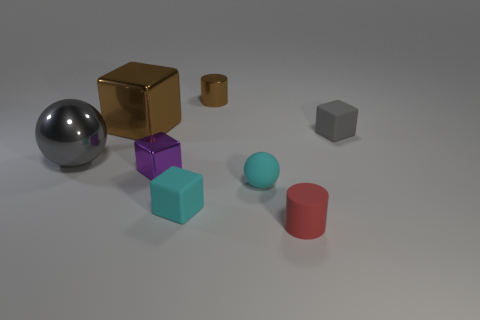Is the rubber cylinder the same color as the matte sphere?
Your answer should be compact. No. The cyan object in front of the ball on the right side of the metal thing that is to the left of the large shiny block is what shape?
Ensure brevity in your answer.  Cube. How many things are metallic things behind the purple block or matte cubes behind the cyan matte ball?
Offer a very short reply. 4. There is a cylinder in front of the cylinder that is behind the tiny gray matte object; how big is it?
Your response must be concise. Small. Is the color of the tiny rubber block on the left side of the tiny shiny cylinder the same as the tiny shiny block?
Offer a terse response. No. Is there a cyan matte object of the same shape as the red thing?
Offer a very short reply. No. What is the color of the shiny cylinder that is the same size as the matte ball?
Provide a short and direct response. Brown. There is a shiny object to the right of the tiny cyan matte block; what is its size?
Offer a very short reply. Small. There is a cylinder behind the tiny red thing; is there a small gray cube behind it?
Give a very brief answer. No. Is the material of the object that is to the left of the brown block the same as the brown block?
Your response must be concise. Yes. 